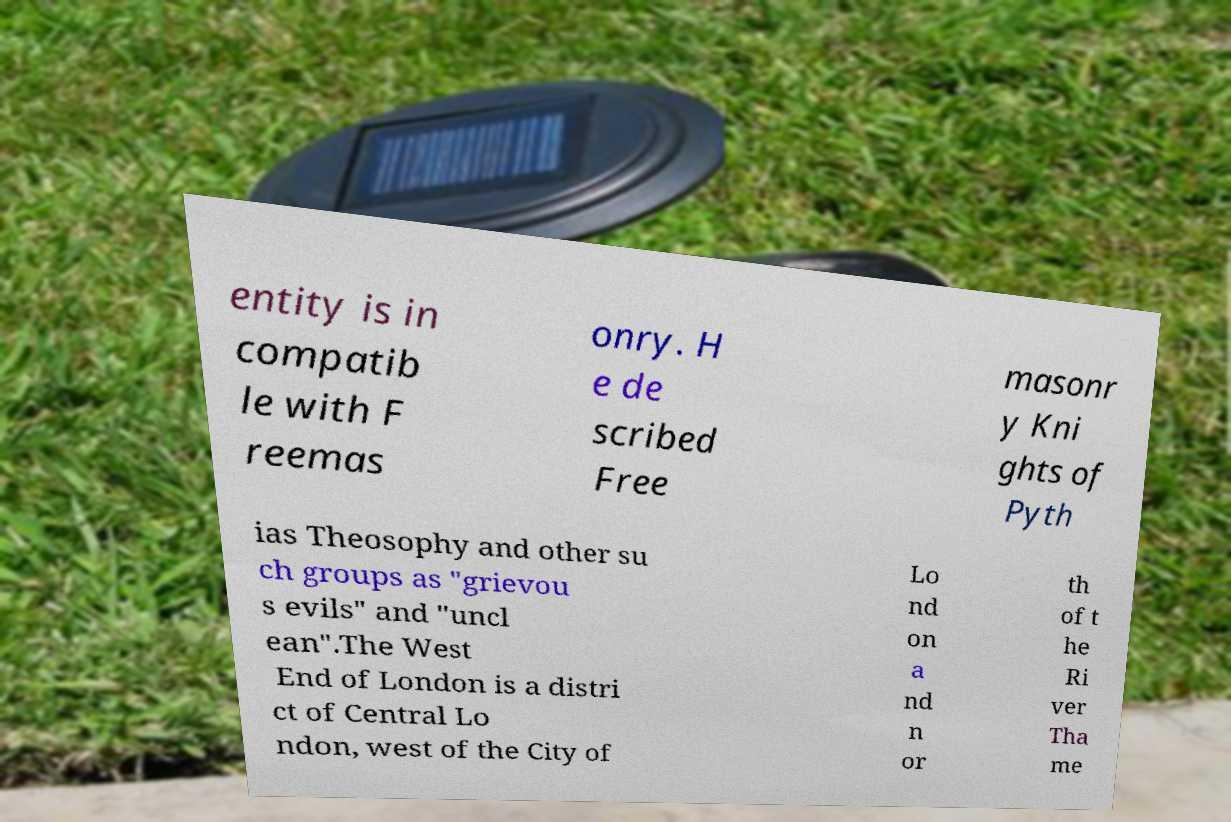Could you assist in decoding the text presented in this image and type it out clearly? entity is in compatib le with F reemas onry. H e de scribed Free masonr y Kni ghts of Pyth ias Theosophy and other su ch groups as "grievou s evils" and "uncl ean".The West End of London is a distri ct of Central Lo ndon, west of the City of Lo nd on a nd n or th of t he Ri ver Tha me 